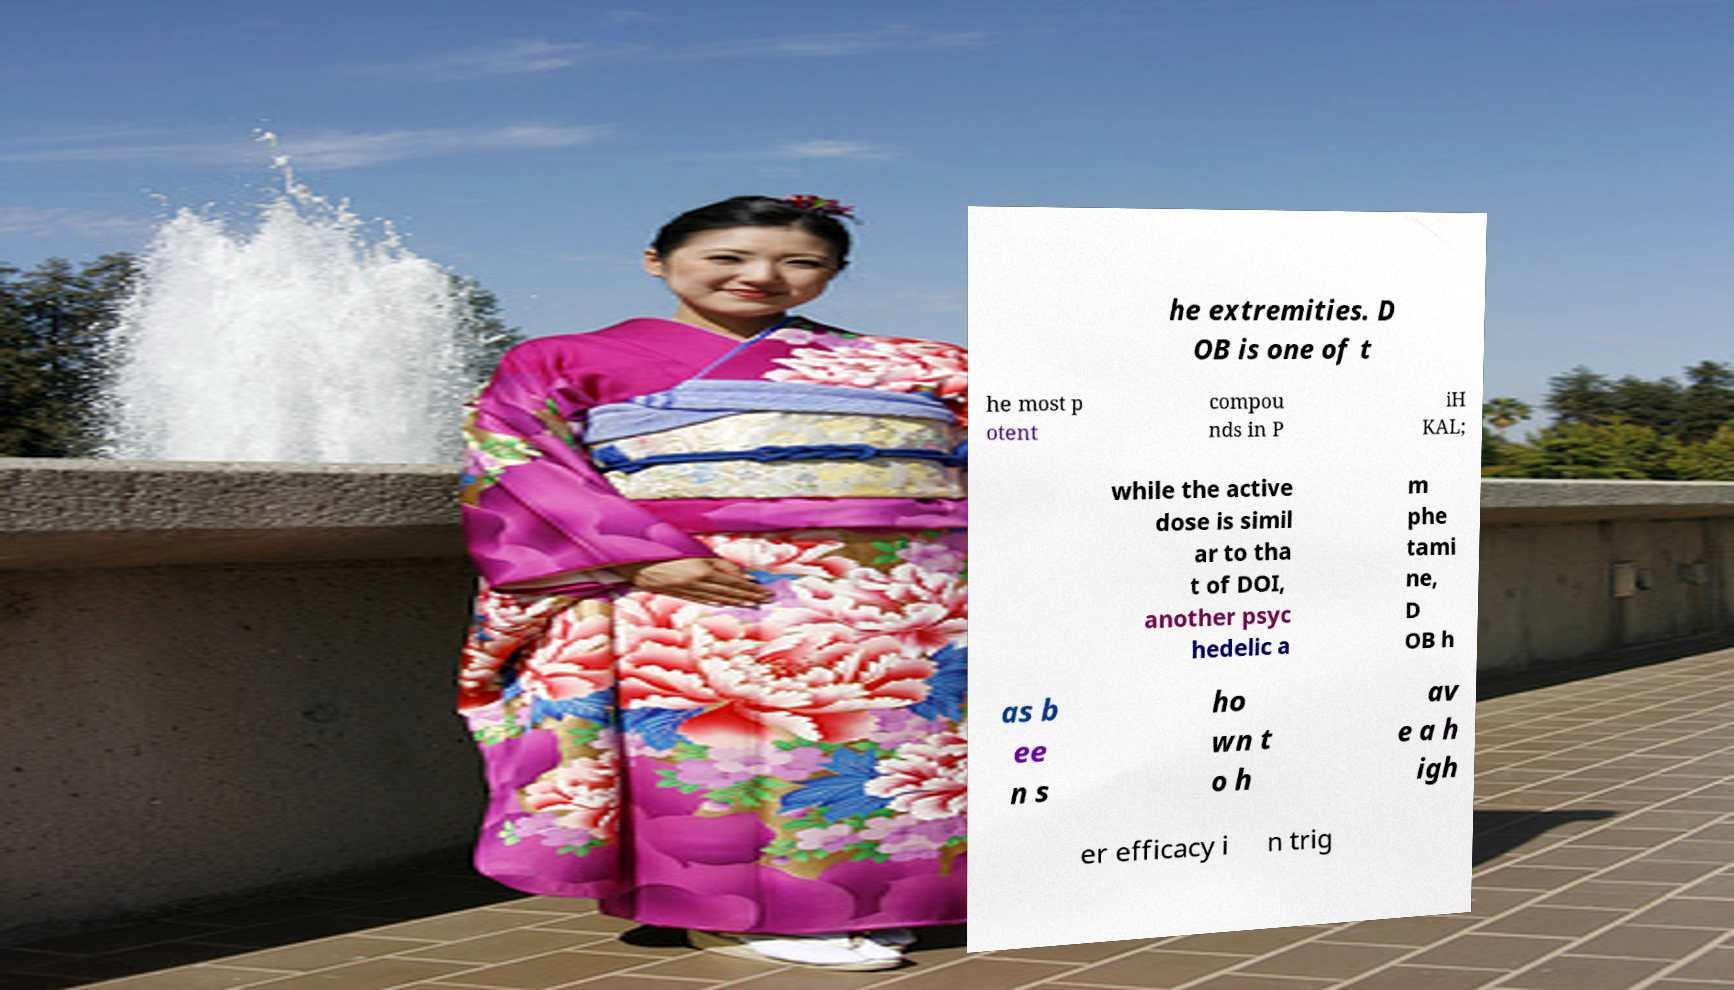I need the written content from this picture converted into text. Can you do that? he extremities. D OB is one of t he most p otent compou nds in P iH KAL; while the active dose is simil ar to tha t of DOI, another psyc hedelic a m phe tami ne, D OB h as b ee n s ho wn t o h av e a h igh er efficacy i n trig 